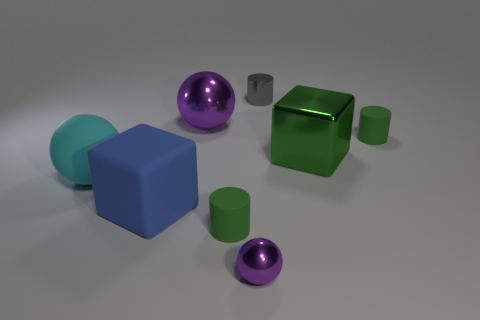Do the small metal sphere and the big metal ball have the same color?
Keep it short and to the point. Yes. Does the big cyan object have the same material as the large purple sphere behind the blue matte object?
Ensure brevity in your answer.  No. There is a cylinder that is the same material as the tiny ball; what size is it?
Offer a very short reply. Small. Are there any blue objects that have the same shape as the green metallic object?
Offer a terse response. Yes. How many objects are large blocks on the left side of the tiny gray object or blue matte objects?
Provide a succinct answer. 1. The other shiny sphere that is the same color as the large metallic sphere is what size?
Offer a very short reply. Small. Does the block on the left side of the metal cylinder have the same color as the tiny cylinder in front of the green shiny block?
Provide a short and direct response. No. How big is the gray cylinder?
Your answer should be compact. Small. How many large objects are either green matte objects or red metallic cylinders?
Keep it short and to the point. 0. There is a metallic block that is the same size as the cyan ball; what is its color?
Give a very brief answer. Green. 